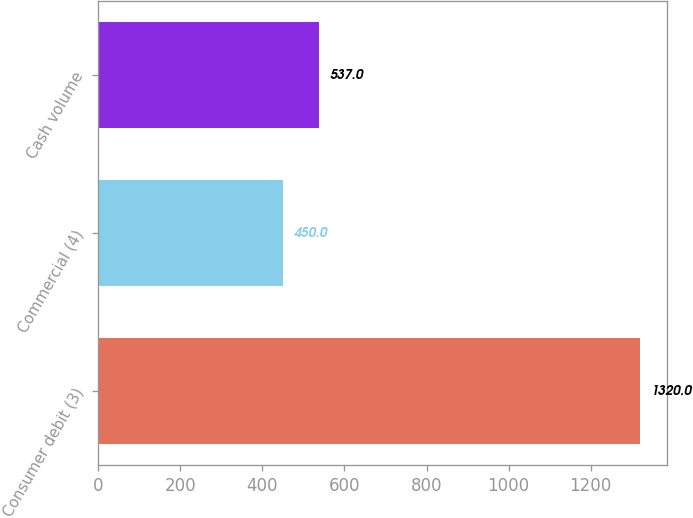Convert chart to OTSL. <chart><loc_0><loc_0><loc_500><loc_500><bar_chart><fcel>Consumer debit (3)<fcel>Commercial (4)<fcel>Cash volume<nl><fcel>1320<fcel>450<fcel>537<nl></chart> 